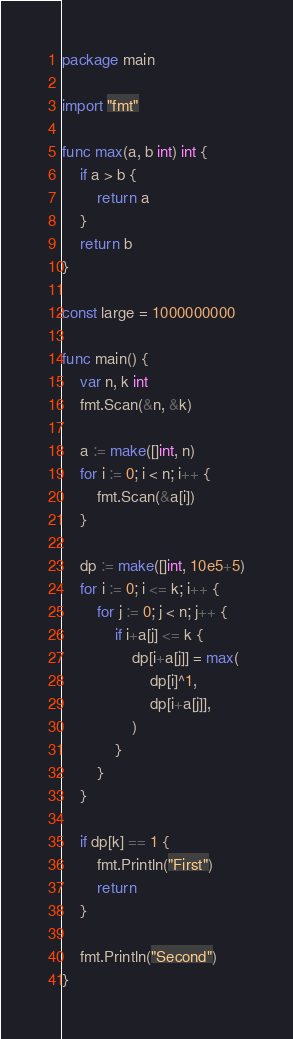Convert code to text. <code><loc_0><loc_0><loc_500><loc_500><_Go_>package main

import "fmt"

func max(a, b int) int {
	if a > b {
		return a
	}
	return b
}

const large = 1000000000

func main() {
	var n, k int
	fmt.Scan(&n, &k)

	a := make([]int, n)
	for i := 0; i < n; i++ {
		fmt.Scan(&a[i])
	}

	dp := make([]int, 10e5+5)
	for i := 0; i <= k; i++ {
		for j := 0; j < n; j++ {
			if i+a[j] <= k {
				dp[i+a[j]] = max(
					dp[i]^1,
					dp[i+a[j]],
				)
			}
		}
	}

	if dp[k] == 1 {
		fmt.Println("First")
		return
	}

	fmt.Println("Second")
}
</code> 